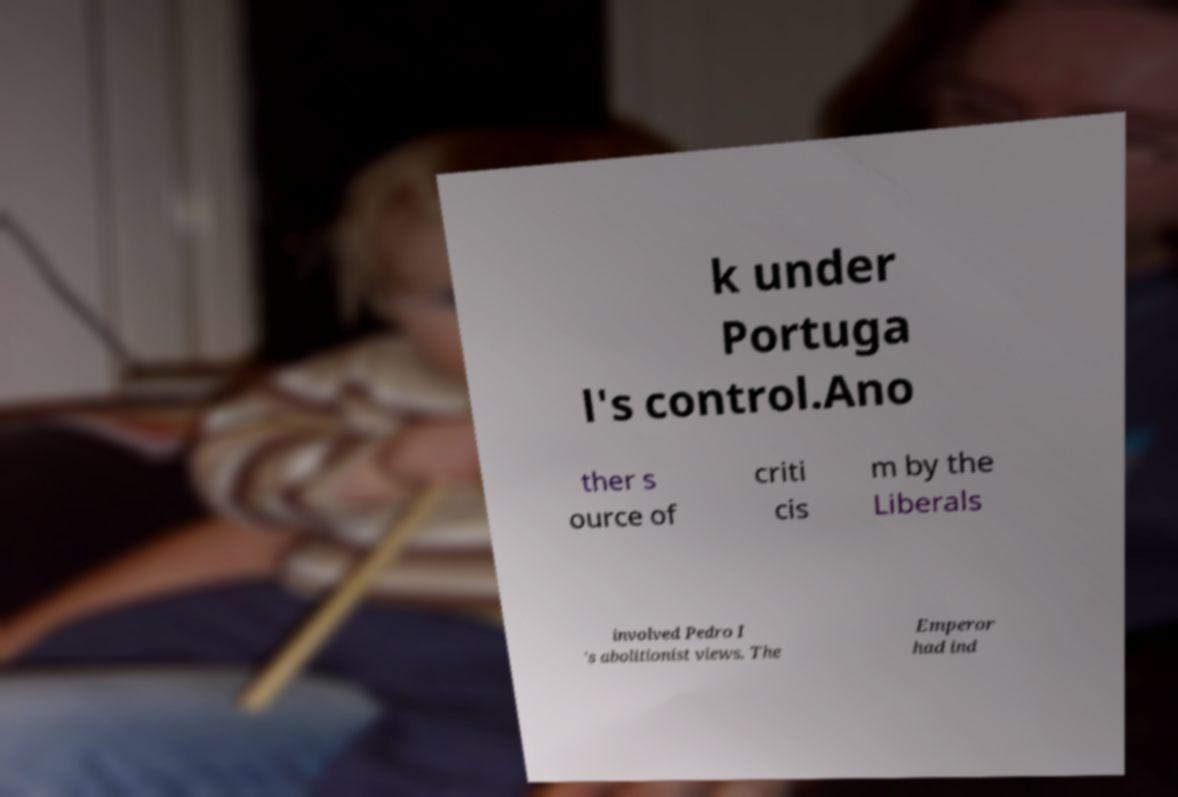Could you extract and type out the text from this image? k under Portuga l's control.Ano ther s ource of criti cis m by the Liberals involved Pedro I 's abolitionist views. The Emperor had ind 